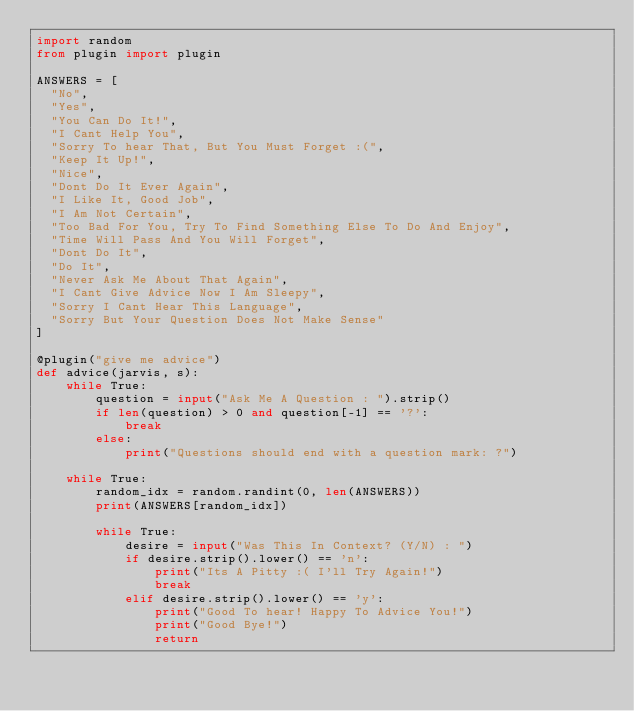Convert code to text. <code><loc_0><loc_0><loc_500><loc_500><_Python_>import random
from plugin import plugin

ANSWERS = [
  "No",
  "Yes",
  "You Can Do It!",
  "I Cant Help You",
  "Sorry To hear That, But You Must Forget :(",
  "Keep It Up!",
  "Nice",
  "Dont Do It Ever Again",
  "I Like It, Good Job",
  "I Am Not Certain",
  "Too Bad For You, Try To Find Something Else To Do And Enjoy",
  "Time Will Pass And You Will Forget",
  "Dont Do It",
  "Do It",
  "Never Ask Me About That Again",
  "I Cant Give Advice Now I Am Sleepy",
  "Sorry I Cant Hear This Language",
  "Sorry But Your Question Does Not Make Sense"
]

@plugin("give me advice")
def advice(jarvis, s):
    while True:
        question = input("Ask Me A Question : ").strip()
        if len(question) > 0 and question[-1] == '?':
            break
        else:
            print("Questions should end with a question mark: ?")

    while True:
        random_idx = random.randint(0, len(ANSWERS))
        print(ANSWERS[random_idx])

        while True:
            desire = input("Was This In Context? (Y/N) : ")
            if desire.strip().lower() == 'n':
                print("Its A Pitty :( I'll Try Again!")
                break
            elif desire.strip().lower() == 'y':
                print("Good To hear! Happy To Advice You!")
                print("Good Bye!")
                return
</code> 